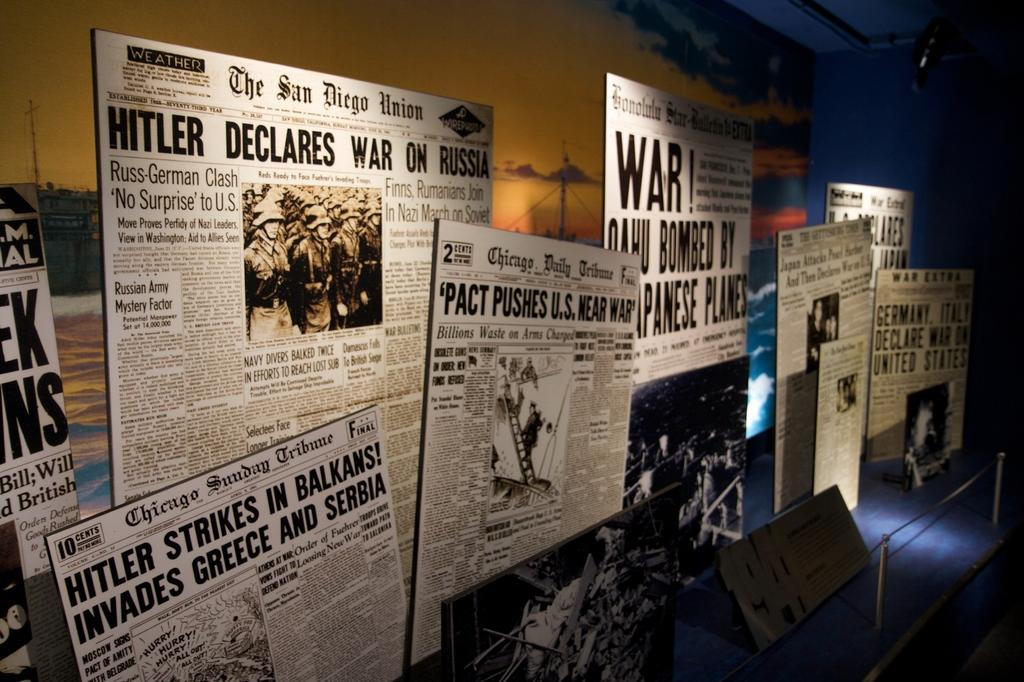<image>
Present a compact description of the photo's key features. Newspapers on a wall with one visible headline reading Hitler Declares War on Russia. 